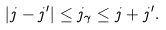Convert formula to latex. <formula><loc_0><loc_0><loc_500><loc_500>| j - j ^ { \prime } | \leq j _ { \gamma } \leq j + j ^ { \prime } .</formula> 